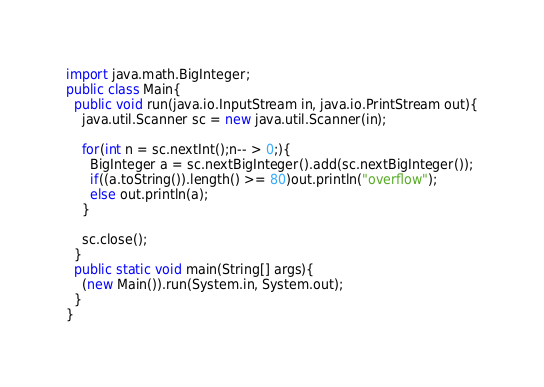Convert code to text. <code><loc_0><loc_0><loc_500><loc_500><_Java_>import java.math.BigInteger;
public class Main{
  public void run(java.io.InputStream in, java.io.PrintStream out){
    java.util.Scanner sc = new java.util.Scanner(in);

    for(int n = sc.nextInt();n-- > 0;){
      BigInteger a = sc.nextBigInteger().add(sc.nextBigInteger());
      if((a.toString()).length() >= 80)out.println("overflow");
      else out.println(a);
    }

    sc.close();
  }
  public static void main(String[] args){
    (new Main()).run(System.in, System.out);
  }
}</code> 